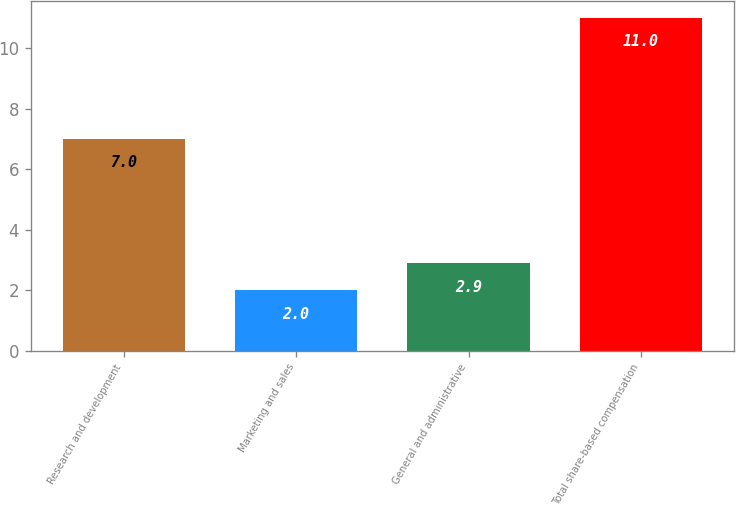Convert chart to OTSL. <chart><loc_0><loc_0><loc_500><loc_500><bar_chart><fcel>Research and development<fcel>Marketing and sales<fcel>General and administrative<fcel>Total share-based compensation<nl><fcel>7<fcel>2<fcel>2.9<fcel>11<nl></chart> 